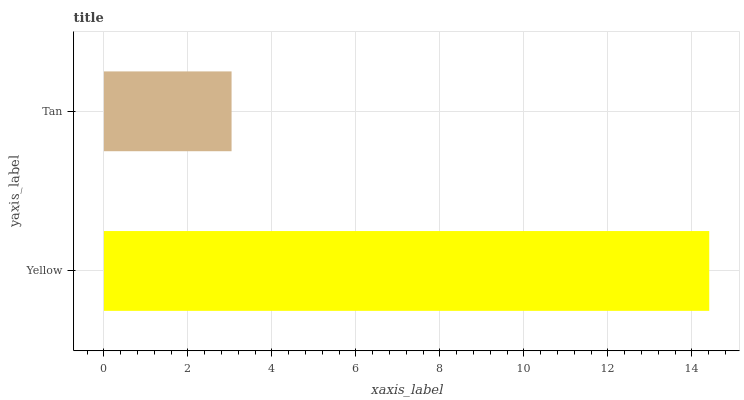Is Tan the minimum?
Answer yes or no. Yes. Is Yellow the maximum?
Answer yes or no. Yes. Is Tan the maximum?
Answer yes or no. No. Is Yellow greater than Tan?
Answer yes or no. Yes. Is Tan less than Yellow?
Answer yes or no. Yes. Is Tan greater than Yellow?
Answer yes or no. No. Is Yellow less than Tan?
Answer yes or no. No. Is Yellow the high median?
Answer yes or no. Yes. Is Tan the low median?
Answer yes or no. Yes. Is Tan the high median?
Answer yes or no. No. Is Yellow the low median?
Answer yes or no. No. 